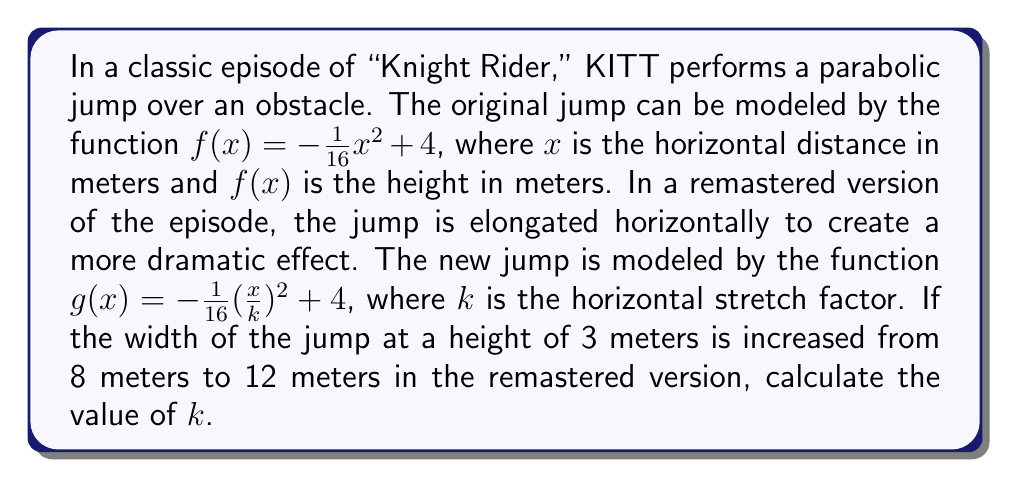Can you solve this math problem? To solve this problem, we'll follow these steps:

1) First, let's find the x-intercepts of $f(x)$ when the height is 3 meters:

   $3 = -\frac{1}{16}x^2 + 4$
   $-1 = -\frac{1}{16}x^2$
   $x^2 = 16$
   $x = \pm 4$

   So the width at 3 meters is 8 meters (from -4 to 4).

2) For the stretched function $g(x)$, we want the width at 3 meters to be 12 meters. This means we're looking for x-values where:

   $3 = -\frac{1}{16}(\frac{x}{k})^2 + 4$

3) Solving this equation:

   $-1 = -\frac{1}{16}(\frac{x}{k})^2$
   $(\frac{x}{k})^2 = 16$
   $\frac{x}{k} = \pm 4$
   $x = \pm 4k$

4) The width is now 12 meters, so:

   $4k - (-4k) = 12$
   $8k = 12$

5) Solving for $k$:

   $k = \frac{12}{8} = 1.5$

Therefore, the horizontal stretch factor is 1.5.
Answer: $k = 1.5$ 